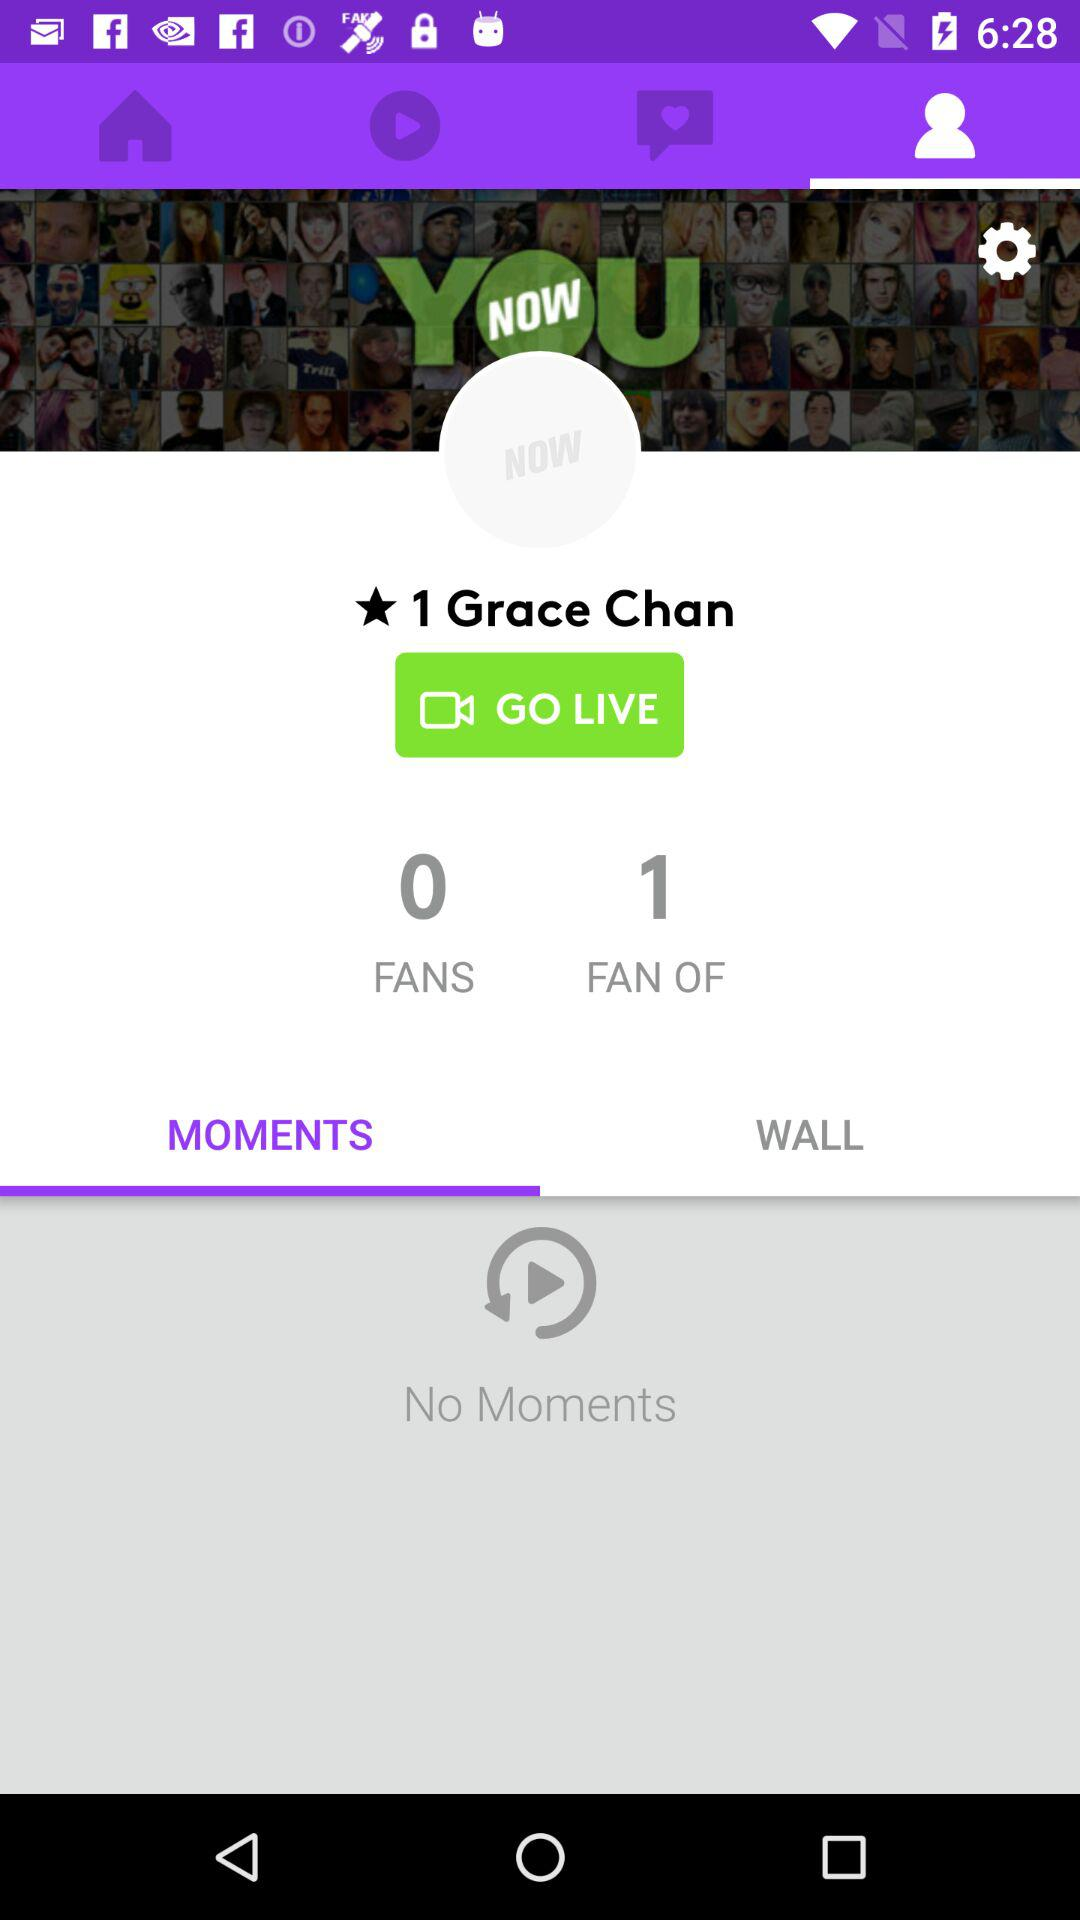How many more fans does Grace Chan have than 0?
Answer the question using a single word or phrase. 1 